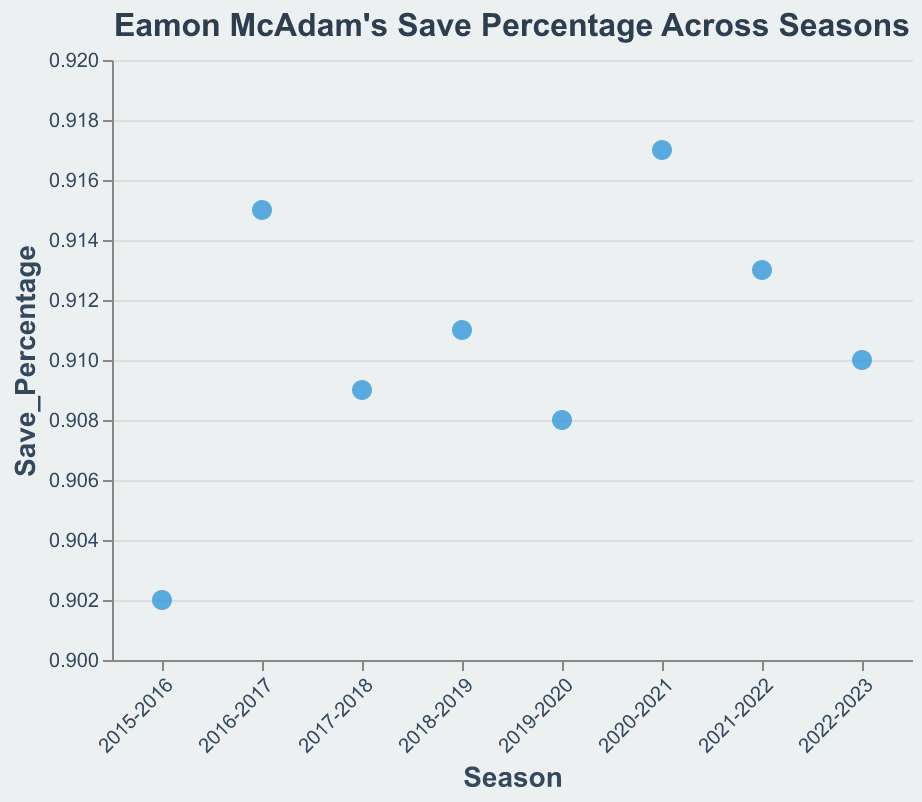What is the title of the figure? The title of the figure is displayed at the top in bold and larger font compared to other text elements. From the visual information, we can see that it reads "Eamon McAdam's Save Percentage Across Seasons".
Answer: Eamon McAdam's Save Percentage Across Seasons What is the save percentage for the 2018-2019 season? Locate the point corresponding to the 2018-2019 season on the x-axis and follow it to the y-axis to read the save percentage value of 0.911.
Answer: 0.911 Which season has the highest save percentage? Identify and compare the positions of all the points relative to the y-axis. The point furthest up corresponds to the highest save percentage, which is the 2020-2021 season with 0.917.
Answer: 2020-2021 What is the average save percentage over the seasons? Sum the save percentages: 0.902 + 0.915 + 0.909 + 0.911 + 0.908 + 0.917 + 0.913 + 0.910 equals 7.285. Then, divide this sum by the number of seasons, which is 8: 7.285 / 8 = 0.910625.
Answer: 0.911 What trend can be observed in Eamon McAdam's save percentage from 2019-2020 to 2022-2023? Compare the relative positions of the points from the 2019-2020 season to the 2022-2023 season. Notice the save percentage slightly increases then decreases: 0.908 to 0.917, down to 0.913, then 0.910.
Answer: Slight decrease Which two consecutive seasons have the greatest increase in save percentage? Look at the differences between consecutive save percentage values for each pair of seasons. The largest increase is between the 2019-2020 (0.908) and the 2020-2021 (0.917) seasons, a difference of 0.009.
Answer: 2019-2020 to 2020-2021 What is the range of save percentages across all seasons? Subtract the smallest save percentage (0.902 in 2015-2016) from the highest save percentage (0.917 in 2020-2021): 0.917 - 0.902 = 0.015.
Answer: 0.015 What save percentage value appears most often? Identify if any value is repeated by checking each save percentage. No value repeats, so no mode exists.
Answer: No mode 